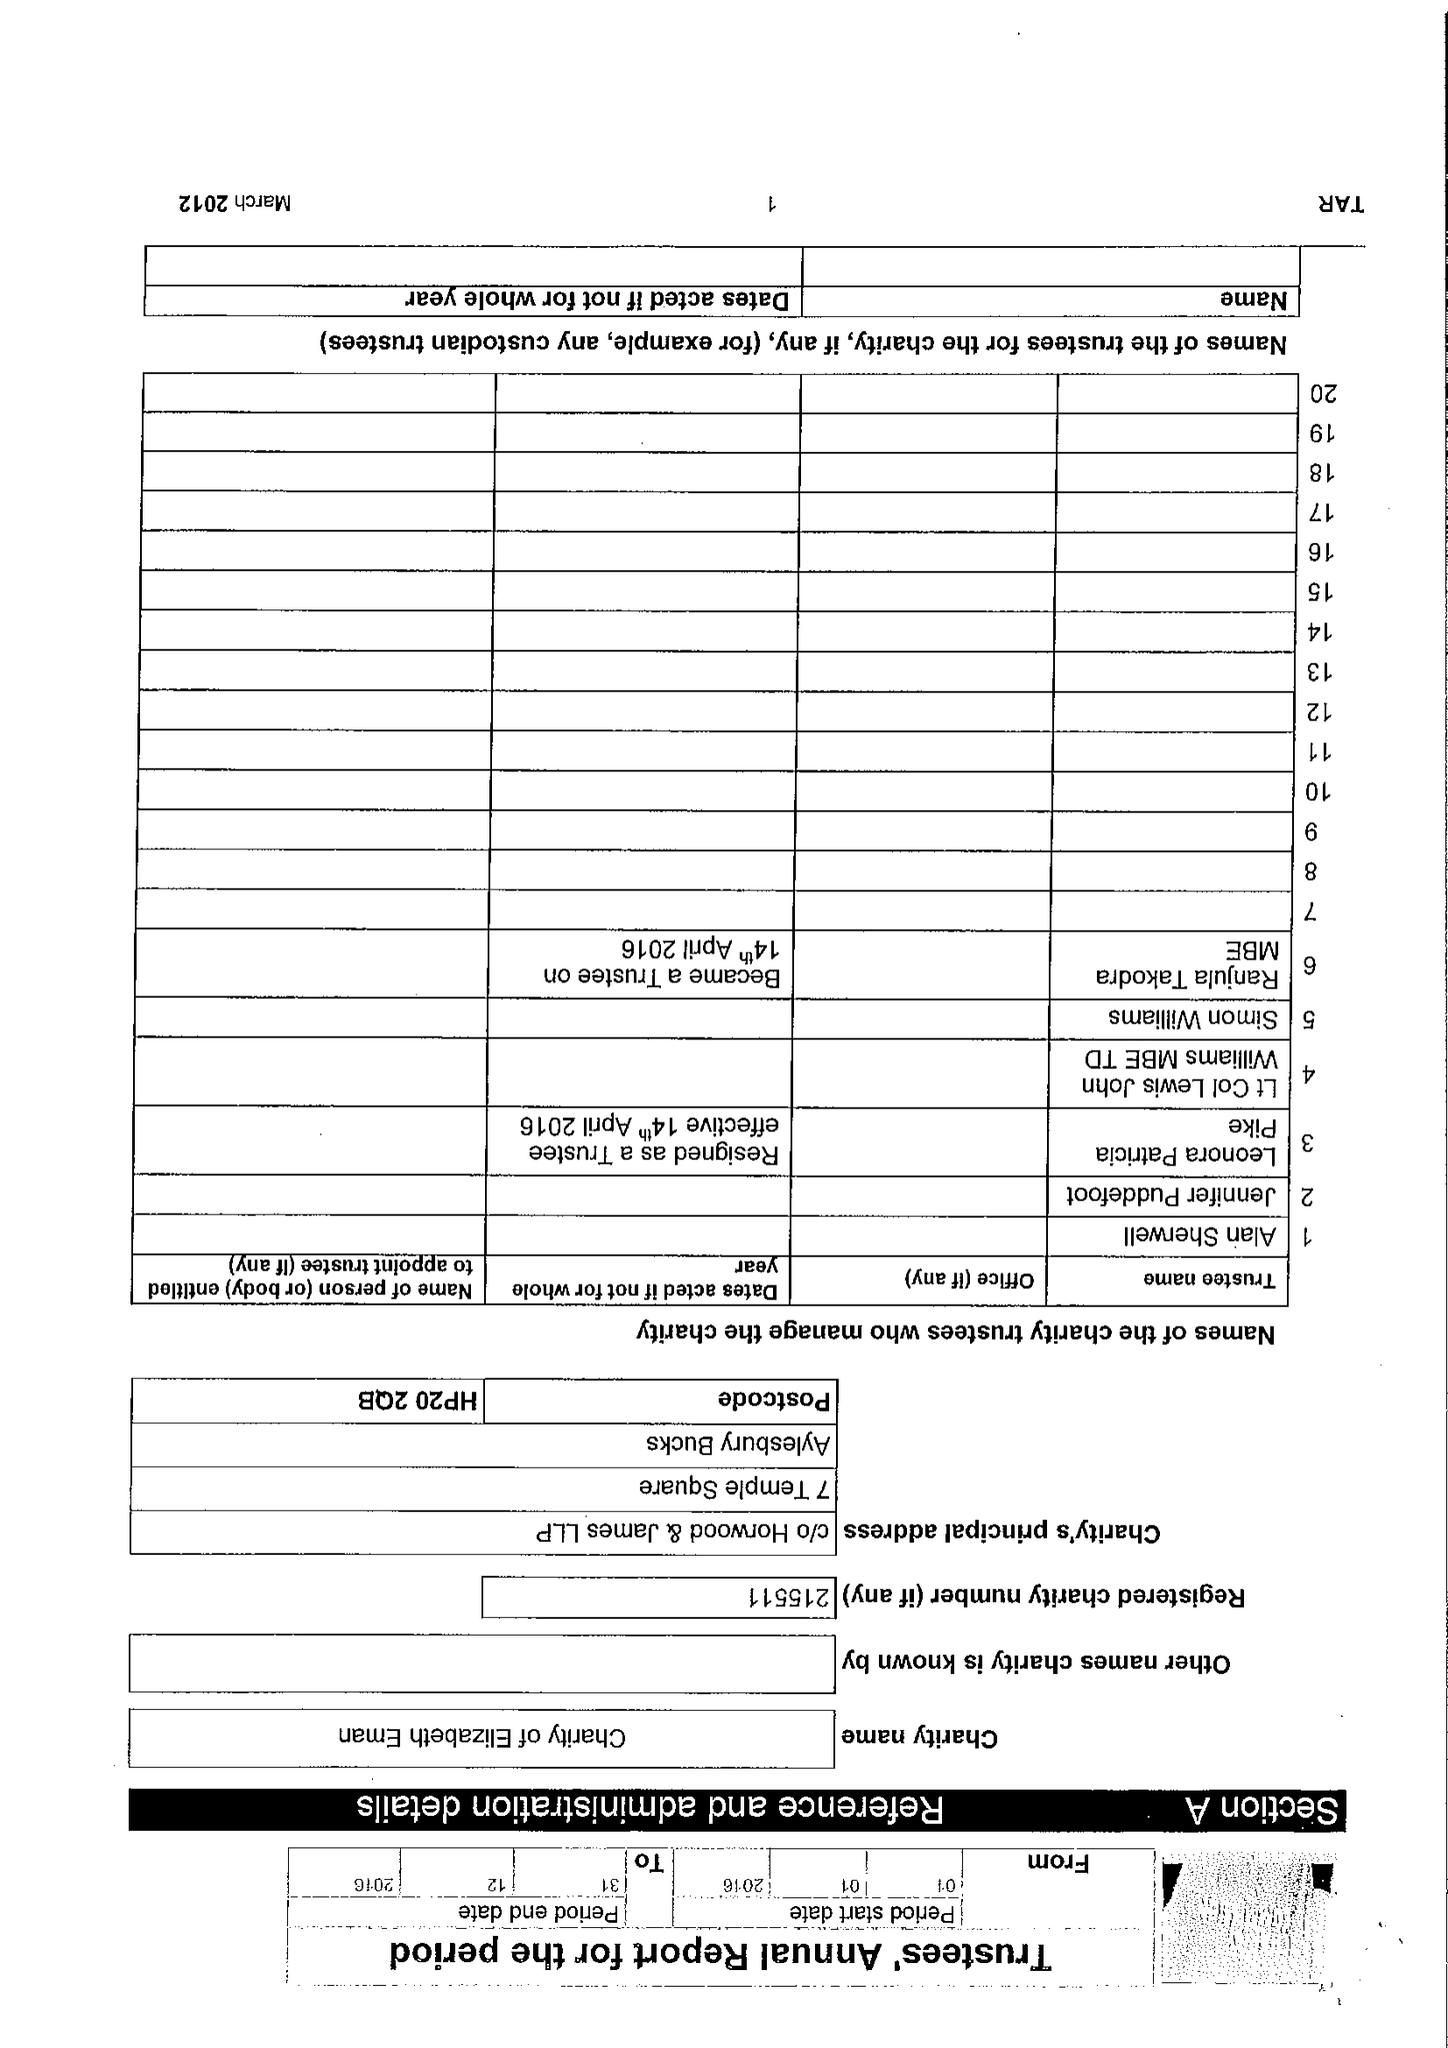What is the value for the address__postcode?
Answer the question using a single word or phrase. HP20 2QB 